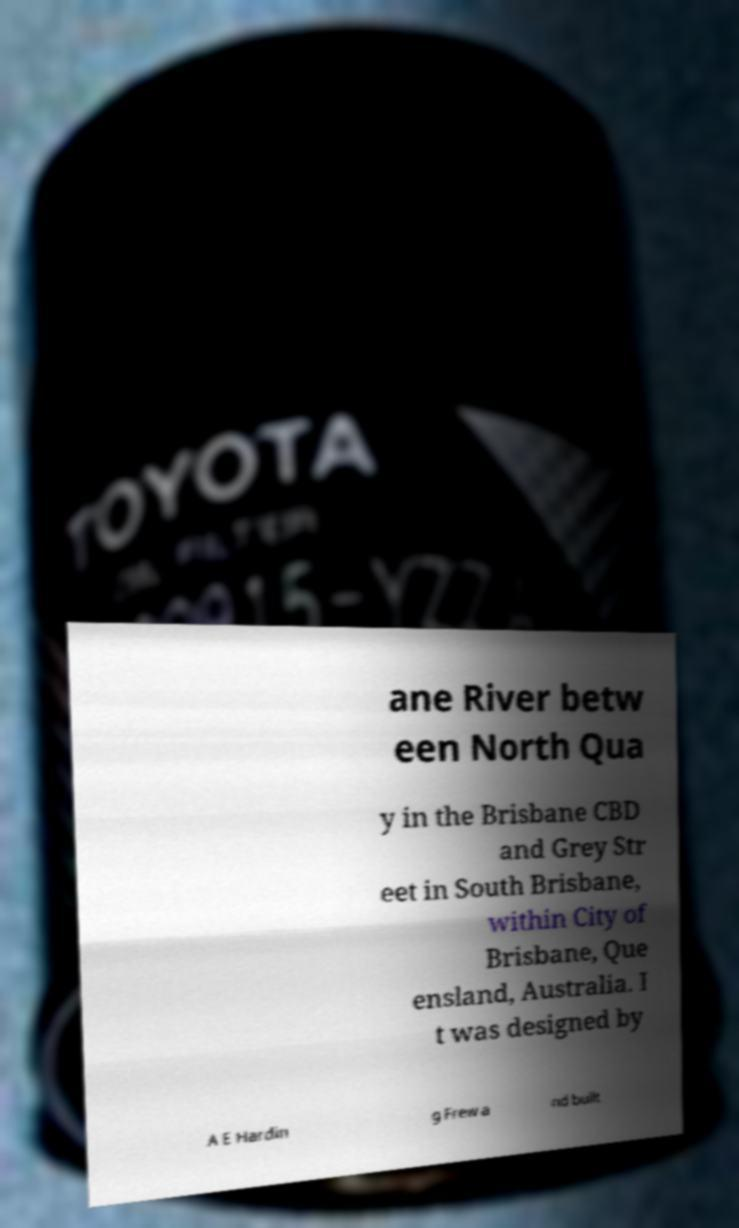I need the written content from this picture converted into text. Can you do that? ane River betw een North Qua y in the Brisbane CBD and Grey Str eet in South Brisbane, within City of Brisbane, Que ensland, Australia. I t was designed by A E Hardin g Frew a nd built 